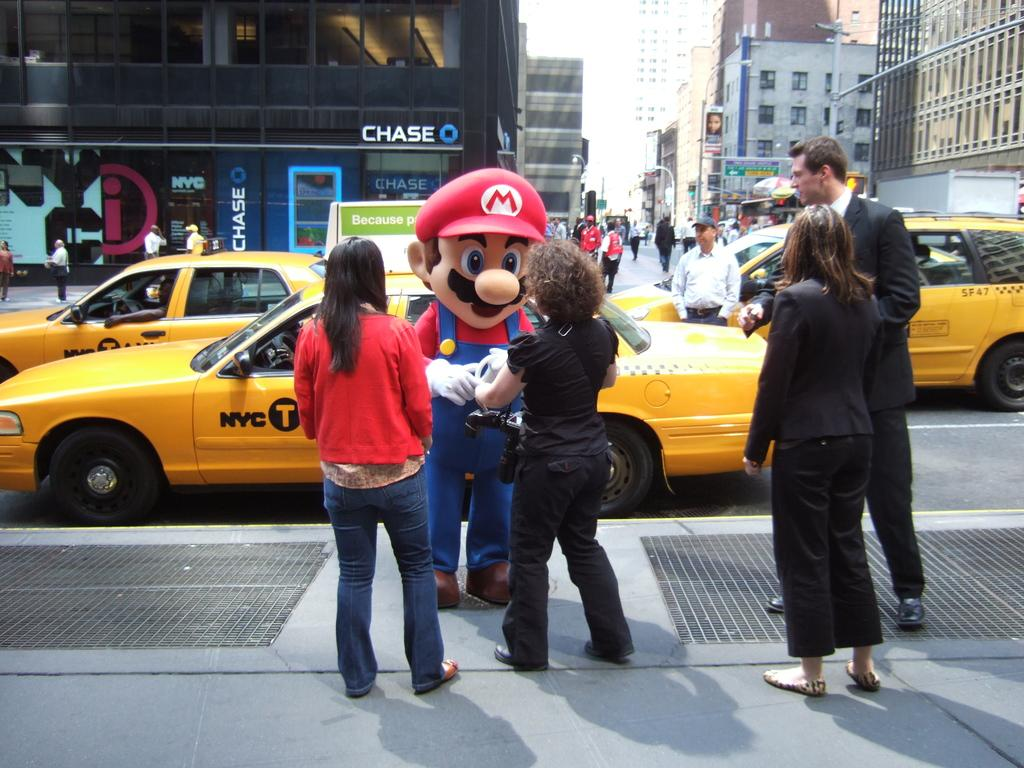<image>
Render a clear and concise summary of the photo. A man dressed as Mario is talking to a group of people next to a yellow car that says NYC Taxi. 